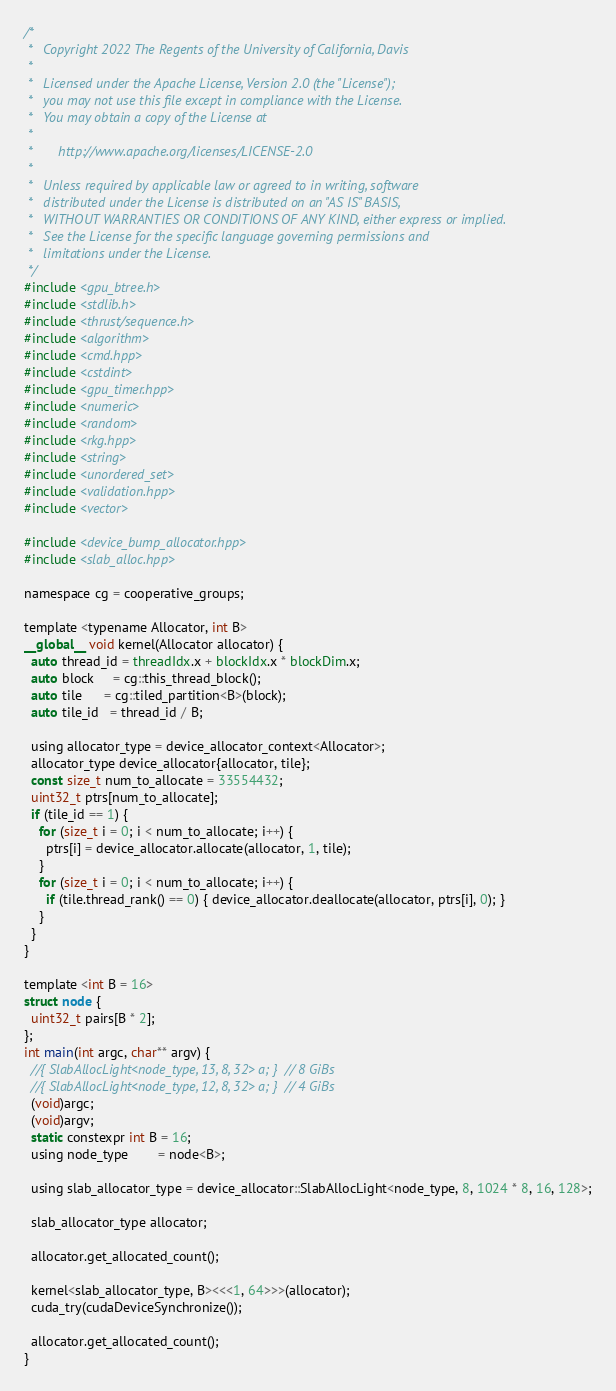<code> <loc_0><loc_0><loc_500><loc_500><_Cuda_>/*
 *   Copyright 2022 The Regents of the University of California, Davis
 *
 *   Licensed under the Apache License, Version 2.0 (the "License");
 *   you may not use this file except in compliance with the License.
 *   You may obtain a copy of the License at
 *
 *       http://www.apache.org/licenses/LICENSE-2.0
 *
 *   Unless required by applicable law or agreed to in writing, software
 *   distributed under the License is distributed on an "AS IS" BASIS,
 *   WITHOUT WARRANTIES OR CONDITIONS OF ANY KIND, either express or implied.
 *   See the License for the specific language governing permissions and
 *   limitations under the License.
 */
#include <gpu_btree.h>
#include <stdlib.h>
#include <thrust/sequence.h>
#include <algorithm>
#include <cmd.hpp>
#include <cstdint>
#include <gpu_timer.hpp>
#include <numeric>
#include <random>
#include <rkg.hpp>
#include <string>
#include <unordered_set>
#include <validation.hpp>
#include <vector>

#include <device_bump_allocator.hpp>
#include <slab_alloc.hpp>

namespace cg = cooperative_groups;

template <typename Allocator, int B>
__global__ void kernel(Allocator allocator) {
  auto thread_id = threadIdx.x + blockIdx.x * blockDim.x;
  auto block     = cg::this_thread_block();
  auto tile      = cg::tiled_partition<B>(block);
  auto tile_id   = thread_id / B;

  using allocator_type = device_allocator_context<Allocator>;
  allocator_type device_allocator{allocator, tile};
  const size_t num_to_allocate = 33554432;
  uint32_t ptrs[num_to_allocate];
  if (tile_id == 1) {
    for (size_t i = 0; i < num_to_allocate; i++) {
      ptrs[i] = device_allocator.allocate(allocator, 1, tile);
    }
    for (size_t i = 0; i < num_to_allocate; i++) {
      if (tile.thread_rank() == 0) { device_allocator.deallocate(allocator, ptrs[i], 0); }
    }
  }
}

template <int B = 16>
struct node {
  uint32_t pairs[B * 2];
};
int main(int argc, char** argv) {
  //{ SlabAllocLight<node_type, 13, 8, 32> a; }  // 8 GiBs
  //{ SlabAllocLight<node_type, 12, 8, 32> a; }  // 4 GiBs
  (void)argc;
  (void)argv;
  static constexpr int B = 16;
  using node_type        = node<B>;

  using slab_allocator_type = device_allocator::SlabAllocLight<node_type, 8, 1024 * 8, 16, 128>;

  slab_allocator_type allocator;

  allocator.get_allocated_count();

  kernel<slab_allocator_type, B><<<1, 64>>>(allocator);
  cuda_try(cudaDeviceSynchronize());

  allocator.get_allocated_count();
}
</code> 